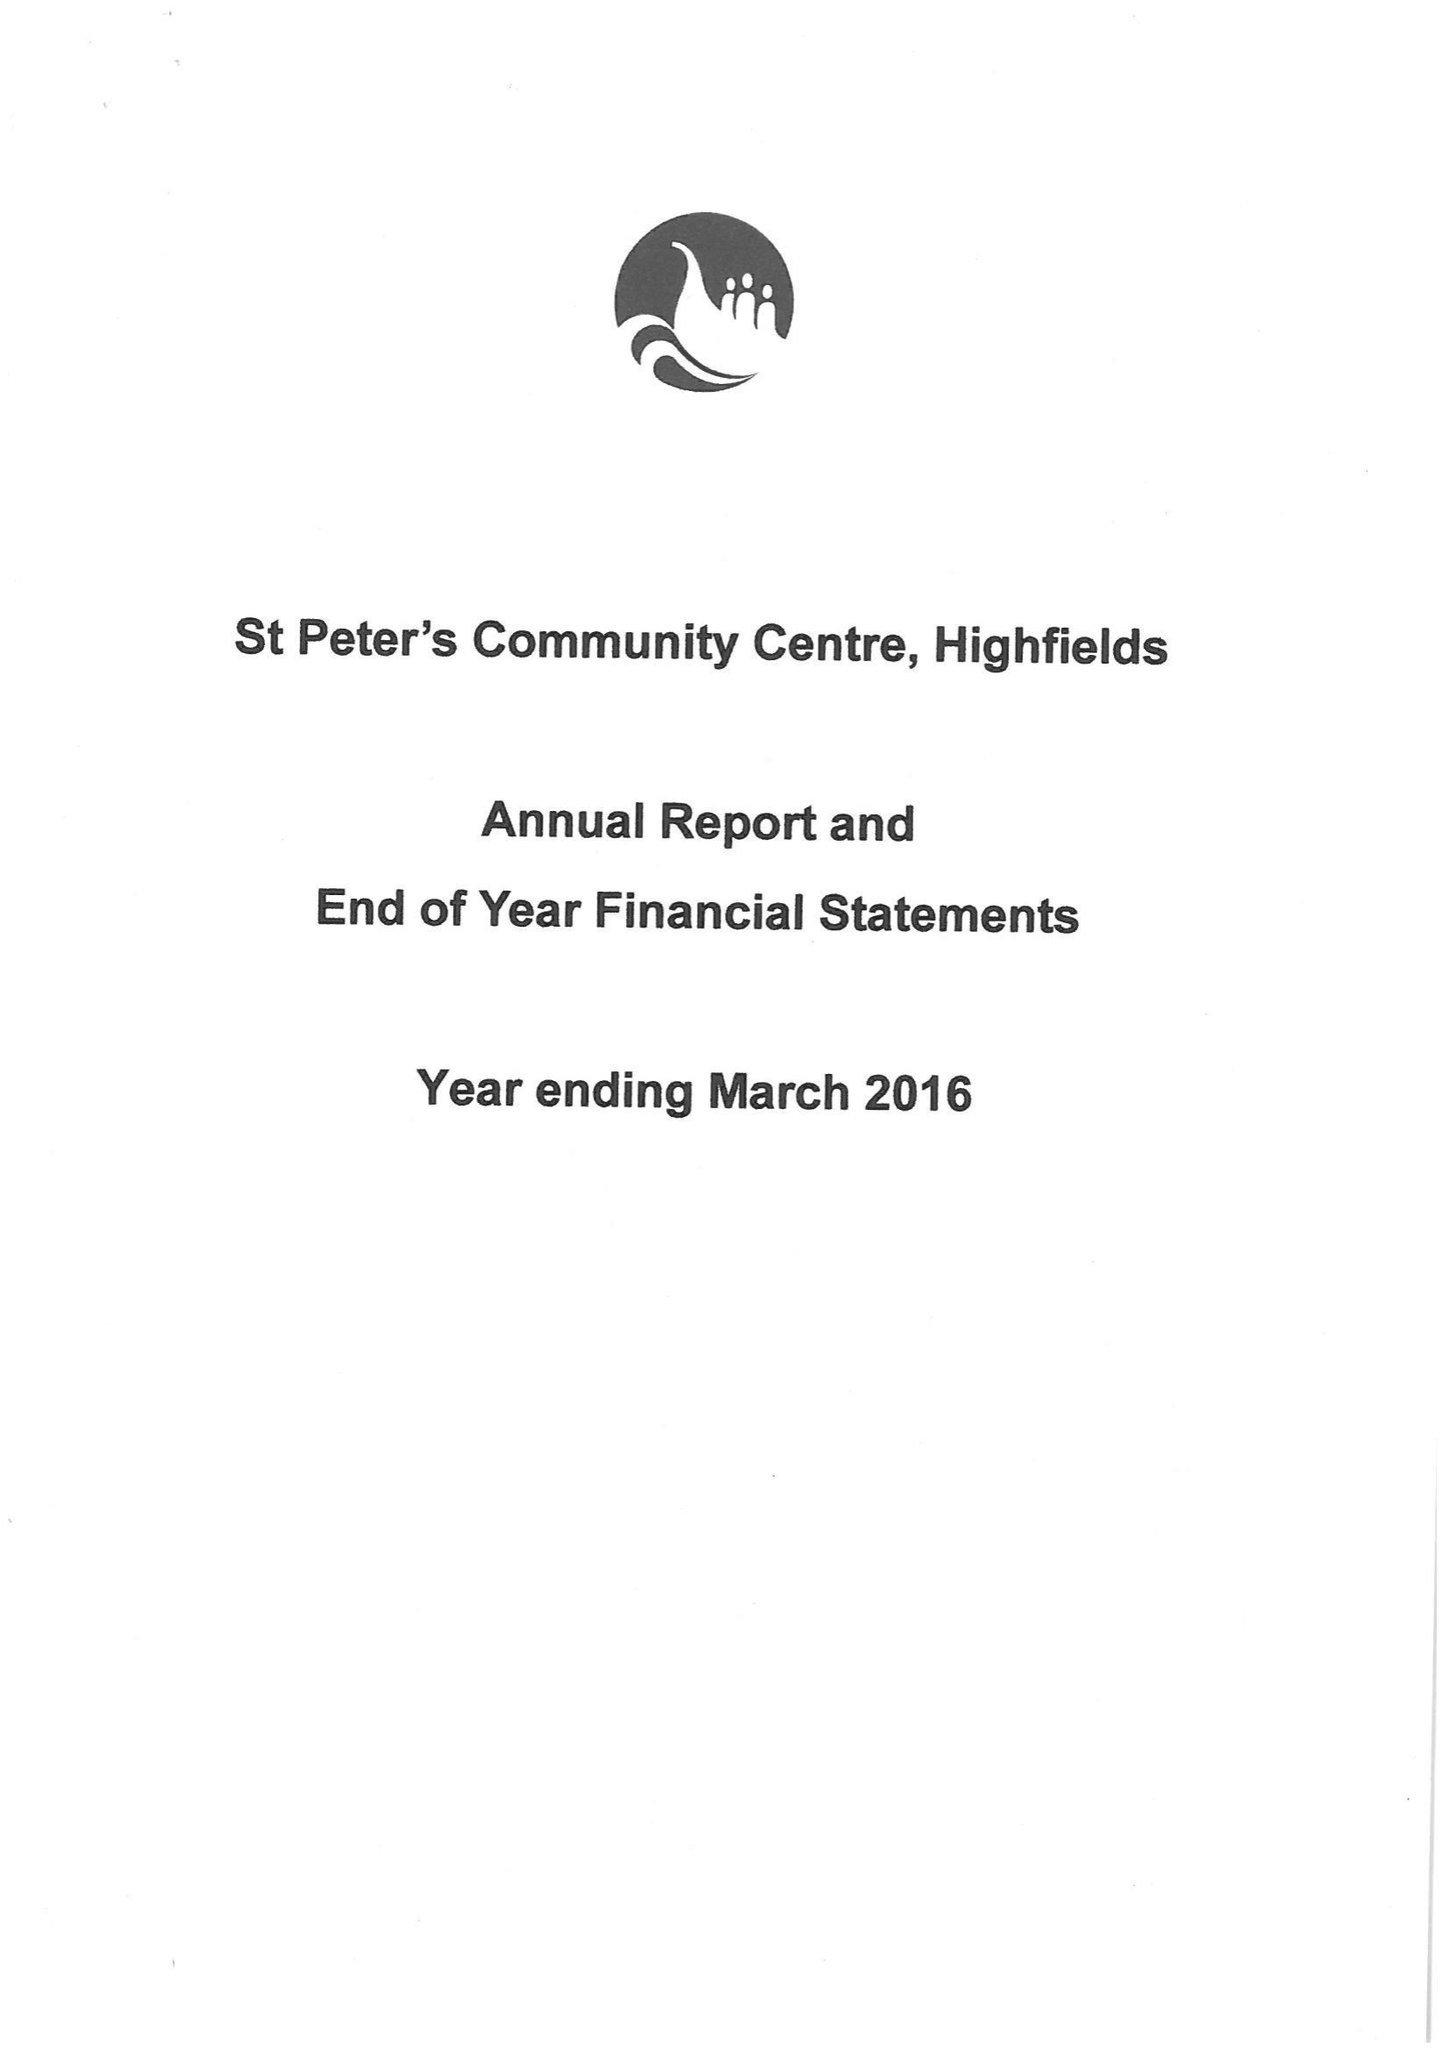What is the value for the address__postcode?
Answer the question using a single word or phrase. None 